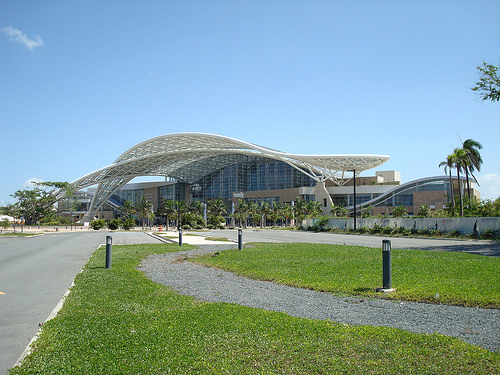<image>
Can you confirm if the post is to the right of the track? Yes. From this viewpoint, the post is positioned to the right side relative to the track. Is the building in front of the grass? No. The building is not in front of the grass. The spatial positioning shows a different relationship between these objects. 